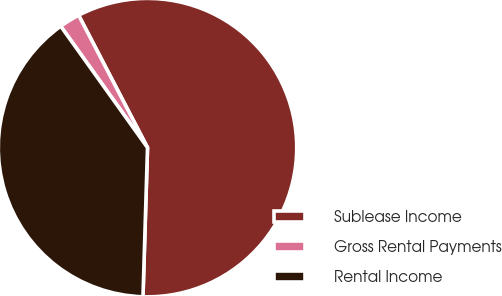Convert chart to OTSL. <chart><loc_0><loc_0><loc_500><loc_500><pie_chart><fcel>Sublease Income<fcel>Gross Rental Payments<fcel>Rental Income<nl><fcel>58.12%<fcel>2.24%<fcel>39.64%<nl></chart> 